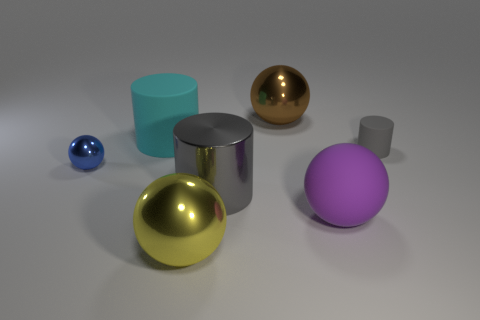Add 1 balls. How many objects exist? 8 Subtract all spheres. How many objects are left? 3 Add 1 tiny cylinders. How many tiny cylinders are left? 2 Add 6 large brown spheres. How many large brown spheres exist? 7 Subtract 0 yellow cylinders. How many objects are left? 7 Subtract all purple rubber spheres. Subtract all cyan matte cylinders. How many objects are left? 5 